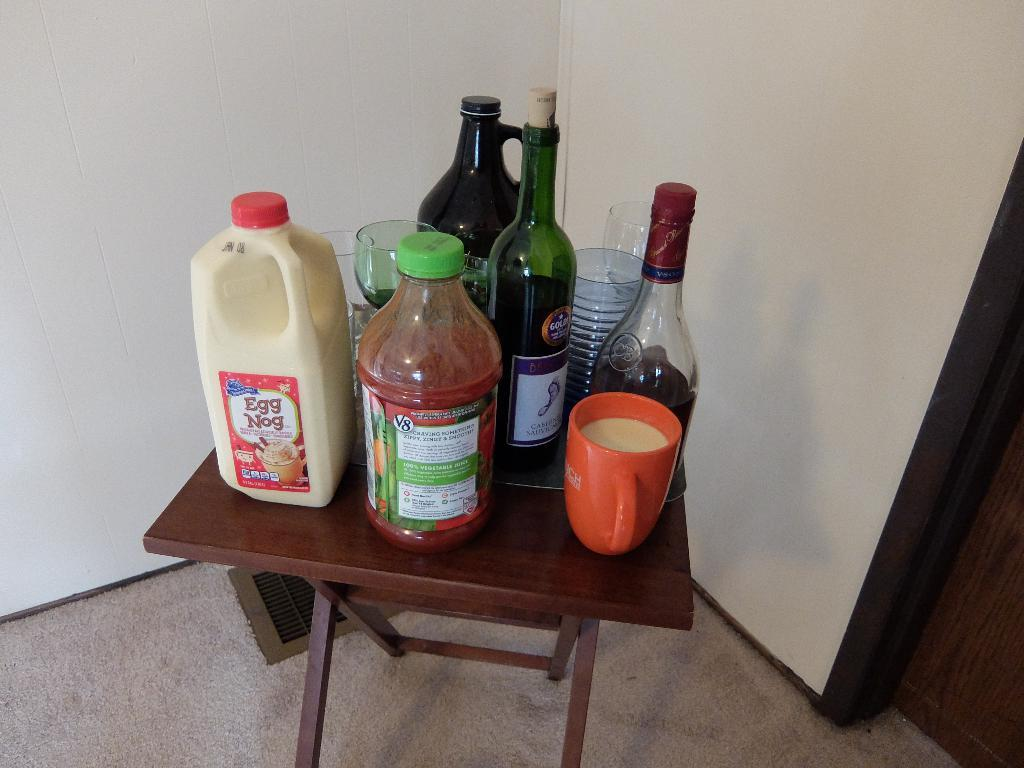<image>
Render a clear and concise summary of the photo. A bottle of egg nog rests on a small table with other beverages. 